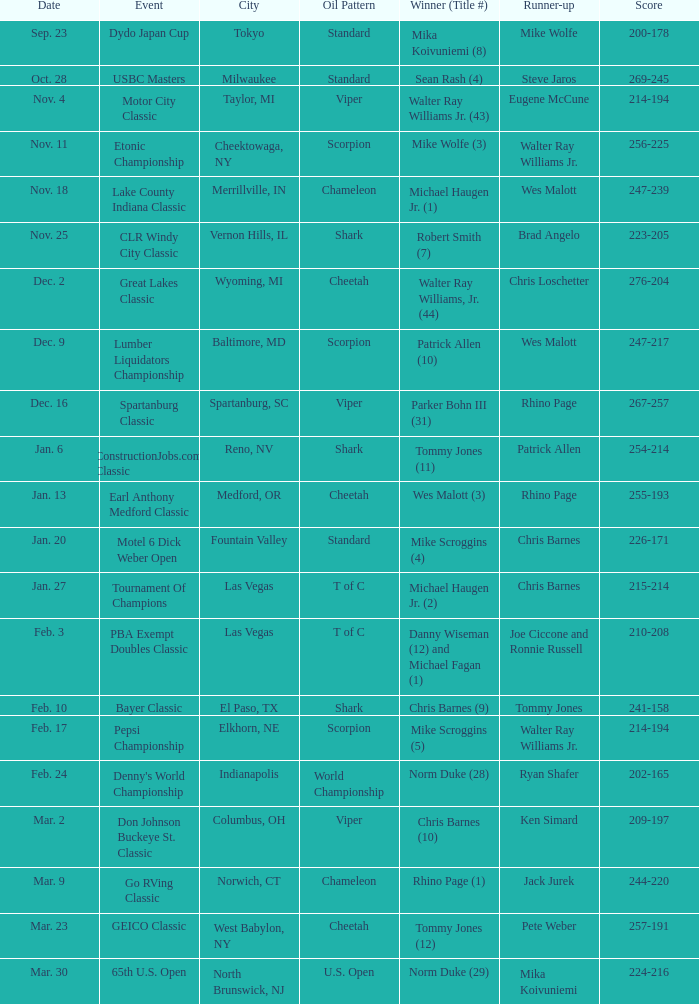Name the Date which has a Oil Pattern of chameleon, and a Event of lake county indiana classic? Nov. 18. 